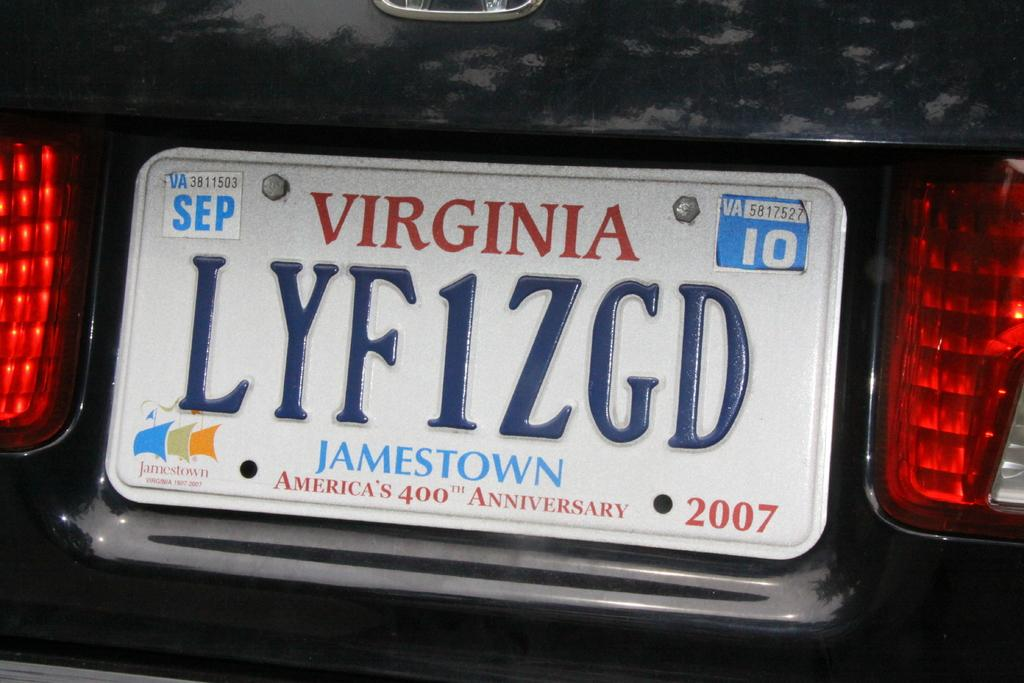<image>
Provide a brief description of the given image. A Virginia license plate displays the city name Jamestown. 